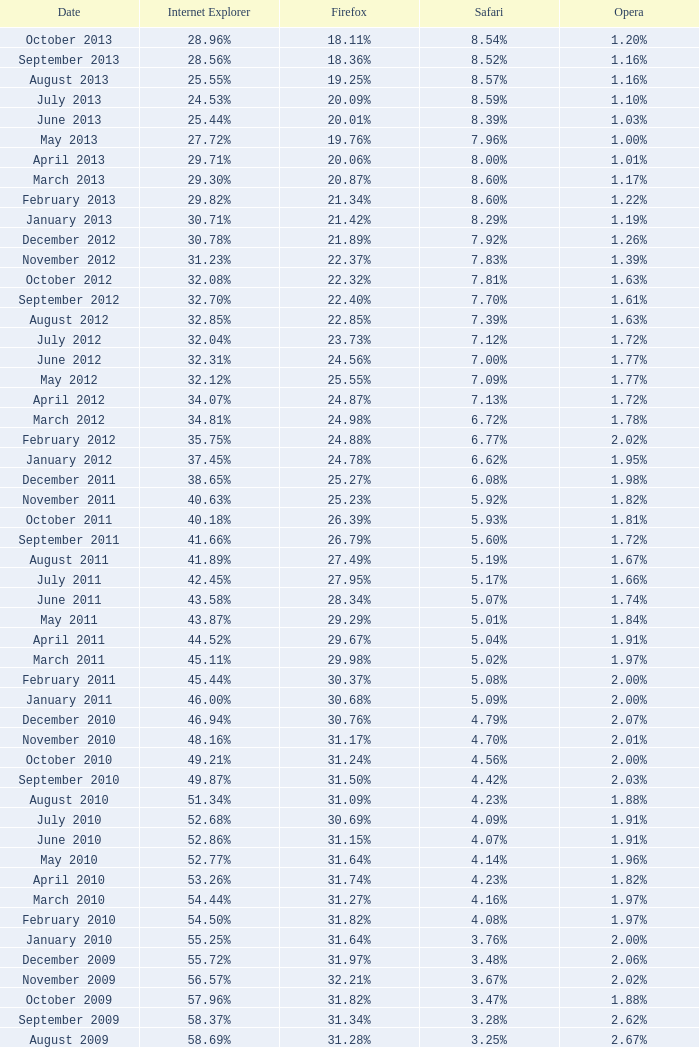27% were engaging with firefox? 4.16%. 